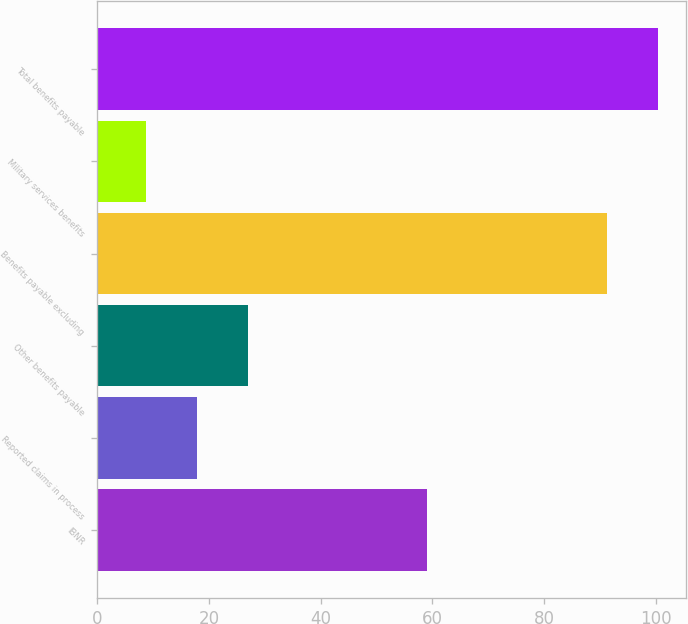Convert chart. <chart><loc_0><loc_0><loc_500><loc_500><bar_chart><fcel>IBNR<fcel>Reported claims in process<fcel>Other benefits payable<fcel>Benefits payable excluding<fcel>Military services benefits<fcel>Total benefits payable<nl><fcel>59<fcel>17.83<fcel>26.96<fcel>91.3<fcel>8.7<fcel>100.43<nl></chart> 